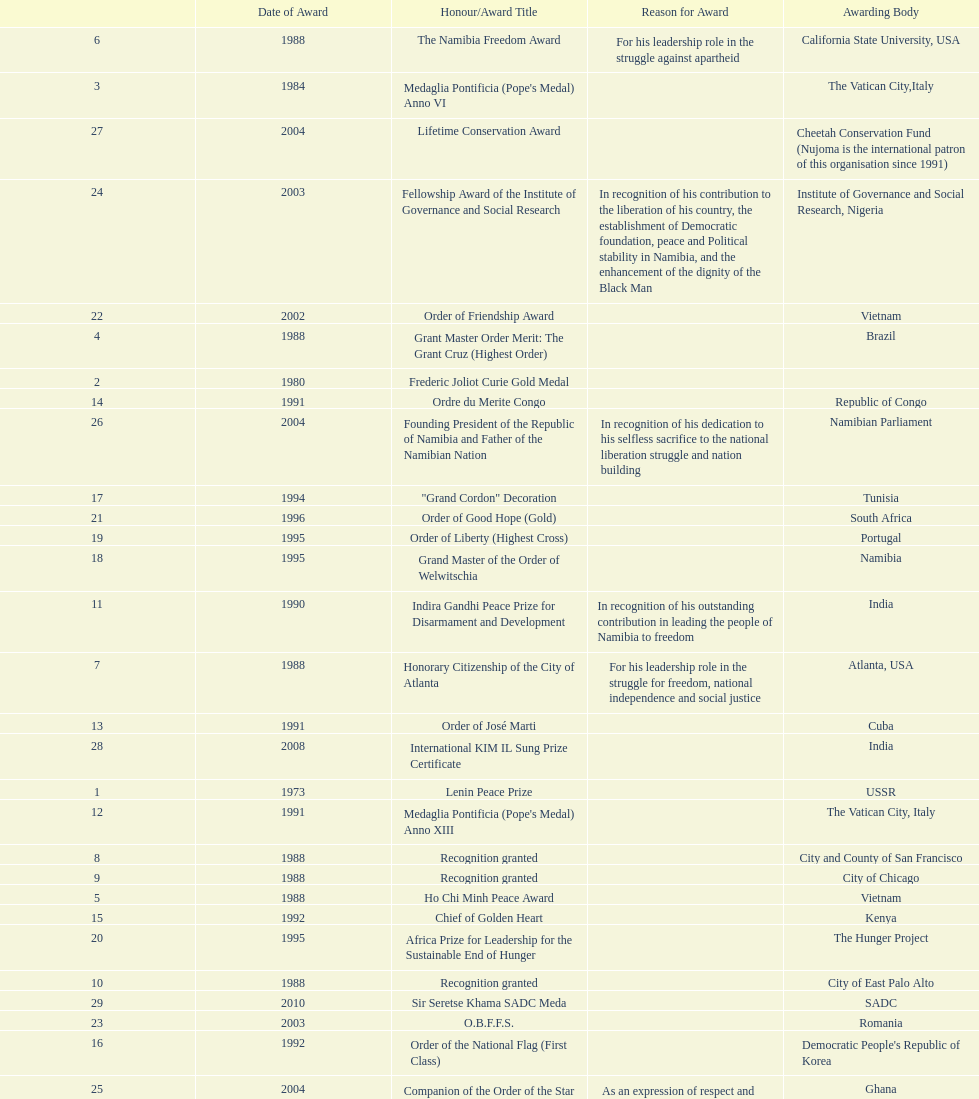I'm looking to parse the entire table for insights. Could you assist me with that? {'header': ['', 'Date of Award', 'Honour/Award Title', 'Reason for Award', 'Awarding Body'], 'rows': [['6', '1988', 'The Namibia Freedom Award', 'For his leadership role in the struggle against apartheid', 'California State University, USA'], ['3', '1984', "Medaglia Pontificia (Pope's Medal) Anno VI", '', 'The Vatican City,Italy'], ['27', '2004', 'Lifetime Conservation Award', '', 'Cheetah Conservation Fund (Nujoma is the international patron of this organisation since 1991)'], ['24', '2003', 'Fellowship Award of the Institute of Governance and Social Research', 'In recognition of his contribution to the liberation of his country, the establishment of Democratic foundation, peace and Political stability in Namibia, and the enhancement of the dignity of the Black Man', 'Institute of Governance and Social Research, Nigeria'], ['22', '2002', 'Order of Friendship Award', '', 'Vietnam'], ['4', '1988', 'Grant Master Order Merit: The Grant Cruz (Highest Order)', '', 'Brazil'], ['2', '1980', 'Frederic Joliot Curie Gold Medal', '', ''], ['14', '1991', 'Ordre du Merite Congo', '', 'Republic of Congo'], ['26', '2004', 'Founding President of the Republic of Namibia and Father of the Namibian Nation', 'In recognition of his dedication to his selfless sacrifice to the national liberation struggle and nation building', 'Namibian Parliament'], ['17', '1994', '"Grand Cordon" Decoration', '', 'Tunisia'], ['21', '1996', 'Order of Good Hope (Gold)', '', 'South Africa'], ['19', '1995', 'Order of Liberty (Highest Cross)', '', 'Portugal'], ['18', '1995', 'Grand Master of the Order of Welwitschia', '', 'Namibia'], ['11', '1990', 'Indira Gandhi Peace Prize for Disarmament and Development', 'In recognition of his outstanding contribution in leading the people of Namibia to freedom', 'India'], ['7', '1988', 'Honorary Citizenship of the City of Atlanta', 'For his leadership role in the struggle for freedom, national independence and social justice', 'Atlanta, USA'], ['13', '1991', 'Order of José Marti', '', 'Cuba'], ['28', '2008', 'International KIM IL Sung Prize Certificate', '', 'India'], ['1', '1973', 'Lenin Peace Prize', '', 'USSR'], ['12', '1991', "Medaglia Pontificia (Pope's Medal) Anno XIII", '', 'The Vatican City, Italy'], ['8', '1988', 'Recognition granted', '', 'City and County of San Francisco'], ['9', '1988', 'Recognition granted', '', 'City of Chicago'], ['5', '1988', 'Ho Chi Minh Peace Award', '', 'Vietnam'], ['15', '1992', 'Chief of Golden Heart', '', 'Kenya'], ['20', '1995', 'Africa Prize for Leadership for the Sustainable End of Hunger', '', 'The Hunger Project'], ['10', '1988', 'Recognition granted', '', 'City of East Palo Alto'], ['29', '2010', 'Sir Seretse Khama SADC Meda', '', 'SADC'], ['23', '2003', 'O.B.F.F.S.', '', 'Romania'], ['16', '1992', 'Order of the National Flag (First Class)', '', "Democratic People's Republic of Korea"], ['25', '2004', 'Companion of the Order of the Star of Ghana (Ghana National Highest Award)', 'As an expression of respect and admiration of the Government and people of Ghana', 'Ghana']]} Did nujoma win the o.b.f.f.s. award in romania or ghana? Romania. 